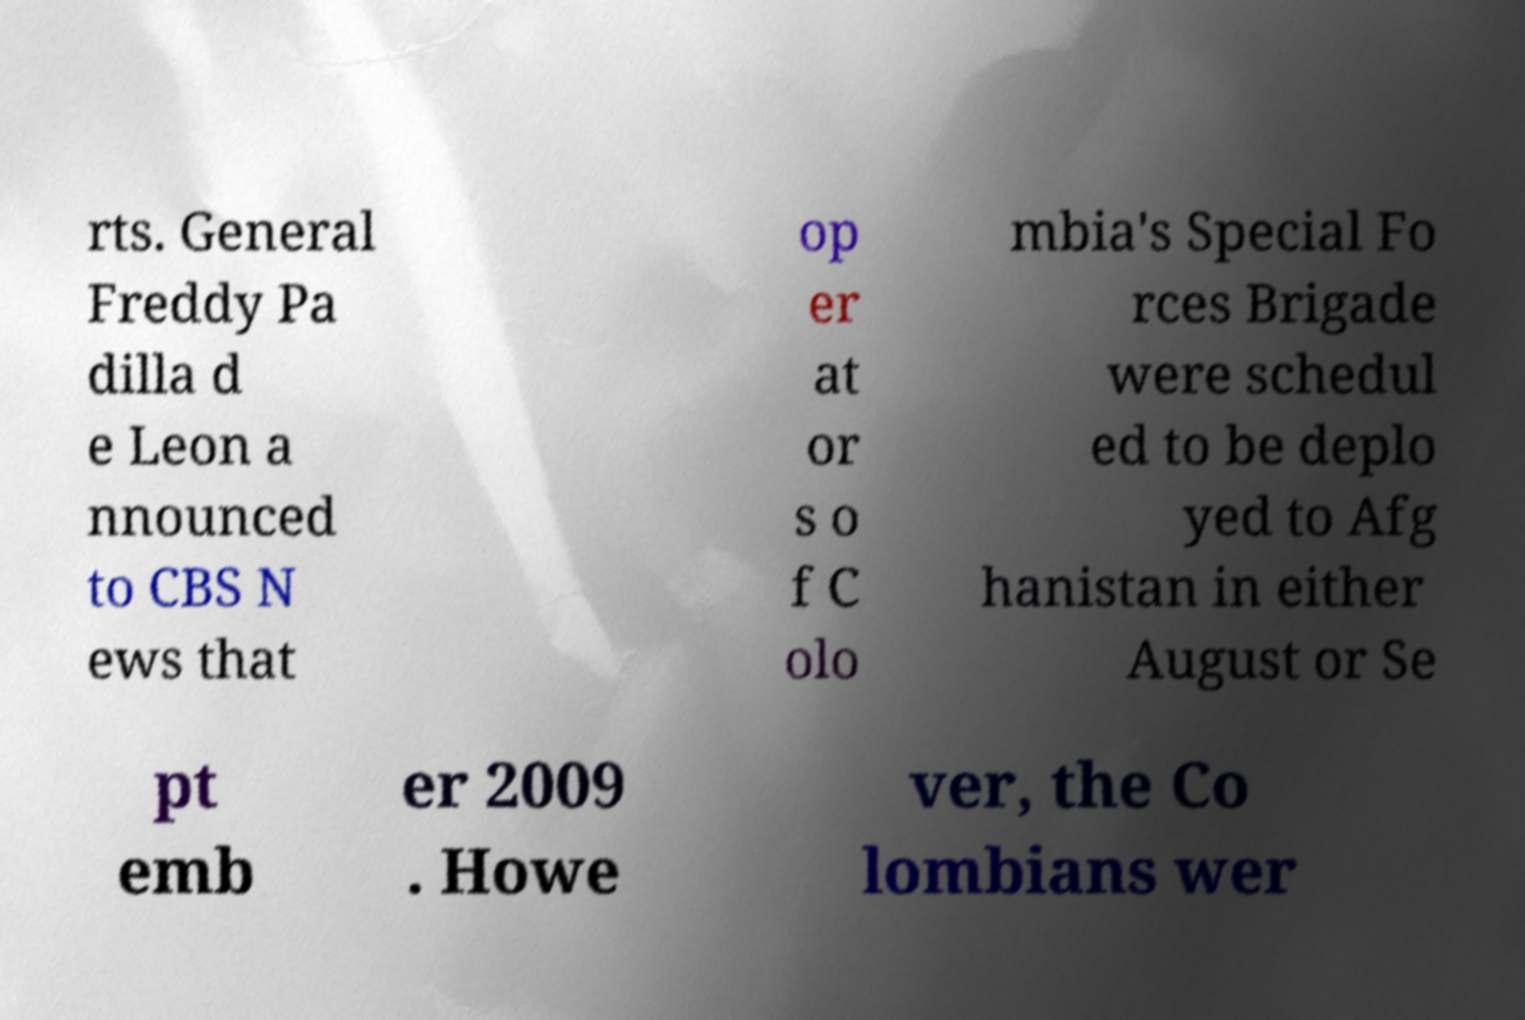Please identify and transcribe the text found in this image. rts. General Freddy Pa dilla d e Leon a nnounced to CBS N ews that op er at or s o f C olo mbia's Special Fo rces Brigade were schedul ed to be deplo yed to Afg hanistan in either August or Se pt emb er 2009 . Howe ver, the Co lombians wer 